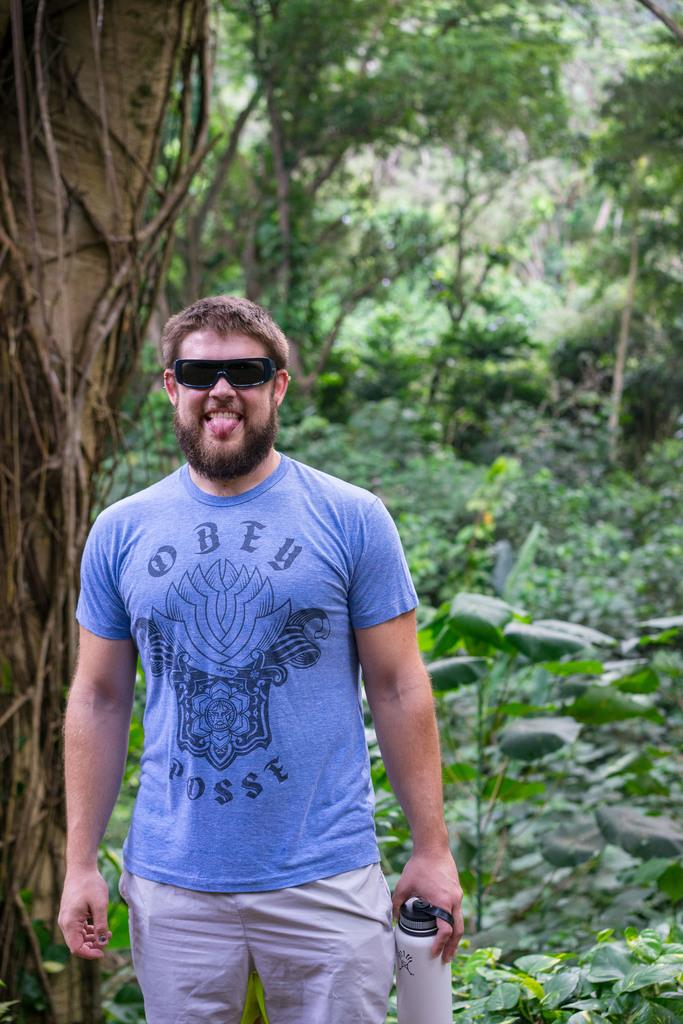What is the person in the image doing? The person is standing in the image. What object is the person holding? The person is holding a bottle. What can be seen in the background of the image? There are trees and plants in the background of the image. What type of blade is the person using to cut the insect in the image? There is no blade or insect present in the image. How many chickens can be seen in the image? There are no chickens present in the image. 